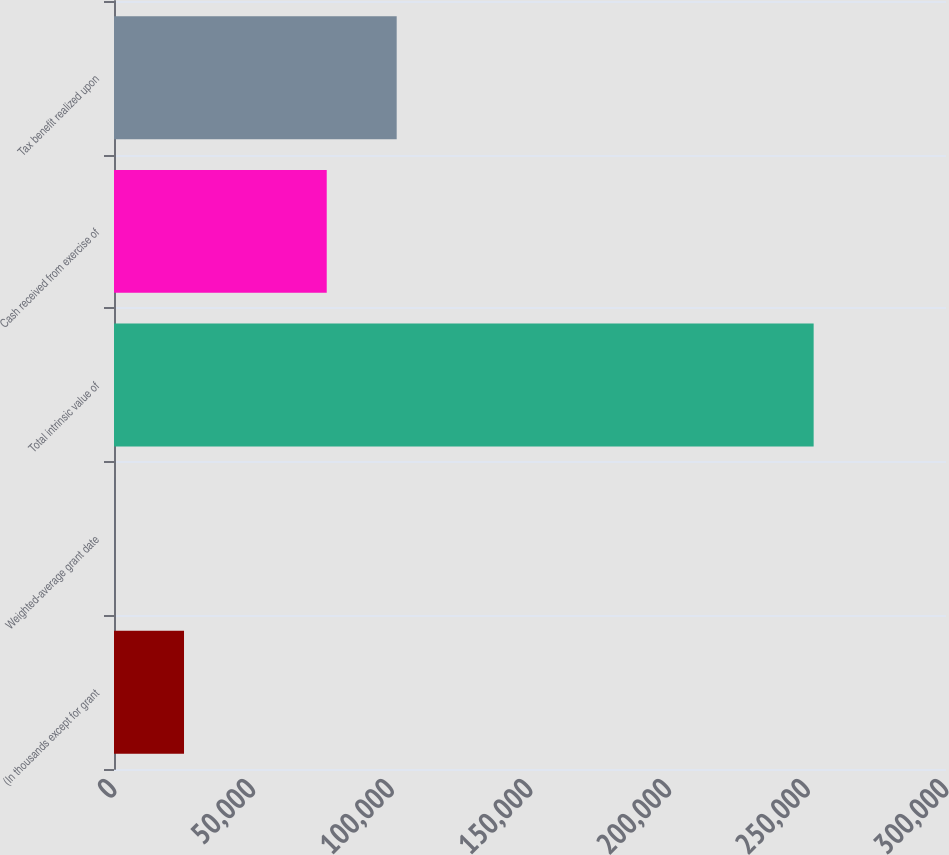<chart> <loc_0><loc_0><loc_500><loc_500><bar_chart><fcel>(In thousands except for grant<fcel>Weighted-average grant date<fcel>Total intrinsic value of<fcel>Cash received from exercise of<fcel>Tax benefit realized upon<nl><fcel>25246.2<fcel>20.5<fcel>252277<fcel>76705<fcel>101931<nl></chart> 